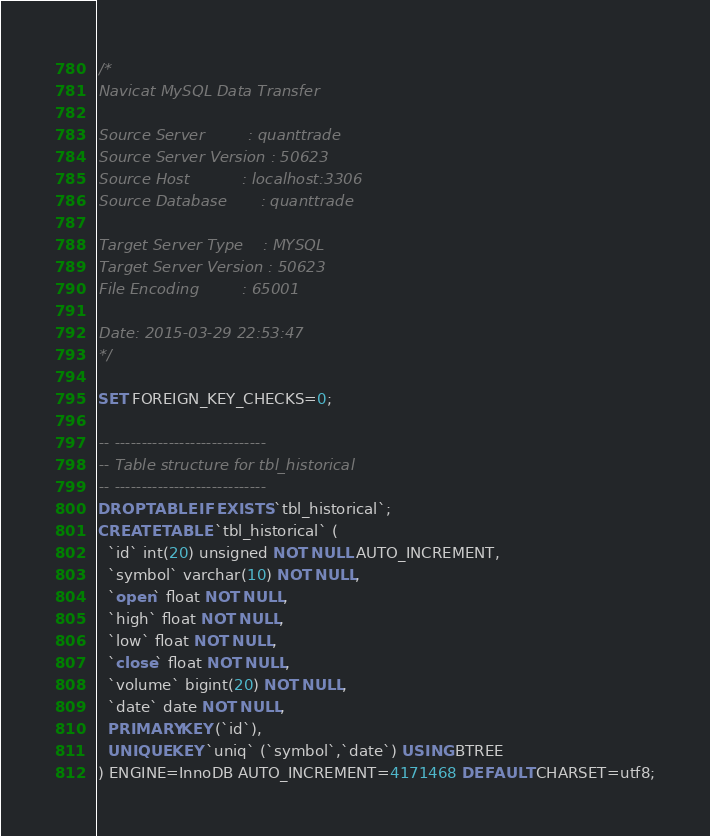<code> <loc_0><loc_0><loc_500><loc_500><_SQL_>/*
Navicat MySQL Data Transfer

Source Server         : quanttrade
Source Server Version : 50623
Source Host           : localhost:3306
Source Database       : quanttrade

Target Server Type    : MYSQL
Target Server Version : 50623
File Encoding         : 65001

Date: 2015-03-29 22:53:47
*/

SET FOREIGN_KEY_CHECKS=0;

-- ----------------------------
-- Table structure for tbl_historical
-- ----------------------------
DROP TABLE IF EXISTS `tbl_historical`;
CREATE TABLE `tbl_historical` (
  `id` int(20) unsigned NOT NULL AUTO_INCREMENT,
  `symbol` varchar(10) NOT NULL,
  `open` float NOT NULL,
  `high` float NOT NULL,
  `low` float NOT NULL,
  `close` float NOT NULL,
  `volume` bigint(20) NOT NULL,
  `date` date NOT NULL,
  PRIMARY KEY (`id`),
  UNIQUE KEY `uniq` (`symbol`,`date`) USING BTREE
) ENGINE=InnoDB AUTO_INCREMENT=4171468 DEFAULT CHARSET=utf8;
</code> 